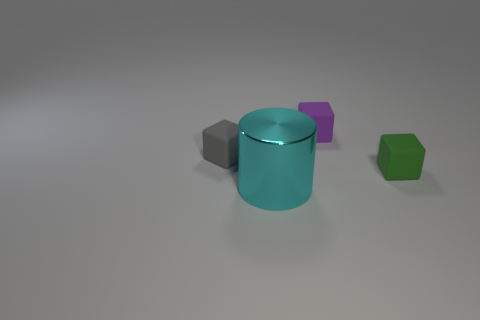Add 4 yellow matte cylinders. How many objects exist? 8 Subtract all cubes. How many objects are left? 1 Subtract 0 red cylinders. How many objects are left? 4 Subtract all blue balls. Subtract all purple matte objects. How many objects are left? 3 Add 2 big cyan cylinders. How many big cyan cylinders are left? 3 Add 4 gray blocks. How many gray blocks exist? 5 